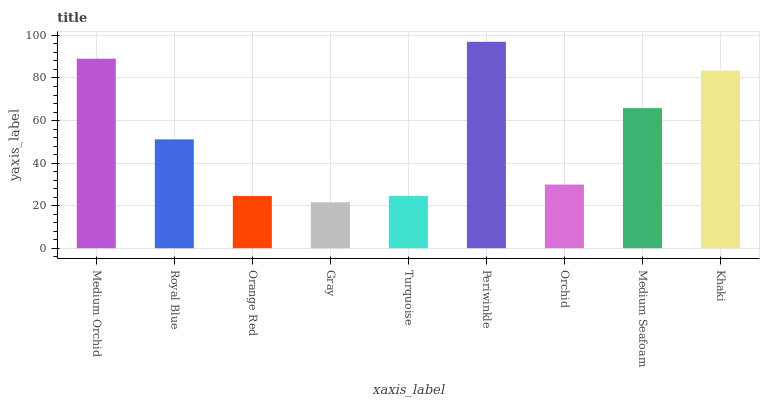Is Gray the minimum?
Answer yes or no. Yes. Is Periwinkle the maximum?
Answer yes or no. Yes. Is Royal Blue the minimum?
Answer yes or no. No. Is Royal Blue the maximum?
Answer yes or no. No. Is Medium Orchid greater than Royal Blue?
Answer yes or no. Yes. Is Royal Blue less than Medium Orchid?
Answer yes or no. Yes. Is Royal Blue greater than Medium Orchid?
Answer yes or no. No. Is Medium Orchid less than Royal Blue?
Answer yes or no. No. Is Royal Blue the high median?
Answer yes or no. Yes. Is Royal Blue the low median?
Answer yes or no. Yes. Is Orange Red the high median?
Answer yes or no. No. Is Periwinkle the low median?
Answer yes or no. No. 